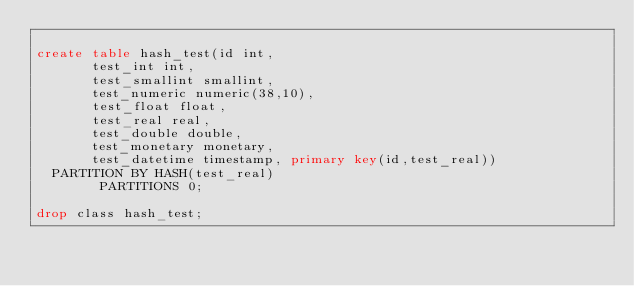Convert code to text. <code><loc_0><loc_0><loc_500><loc_500><_SQL_>
create table hash_test(id int,
			 test_int int,
			 test_smallint smallint,
			 test_numeric numeric(38,10),
			 test_float float,
			 test_real real,
			 test_double double,
			 test_monetary monetary,
			 test_datetime timestamp, primary key(id,test_real))
	PARTITION BY HASH(test_real)
        PARTITIONS 0;

drop class hash_test;
</code> 